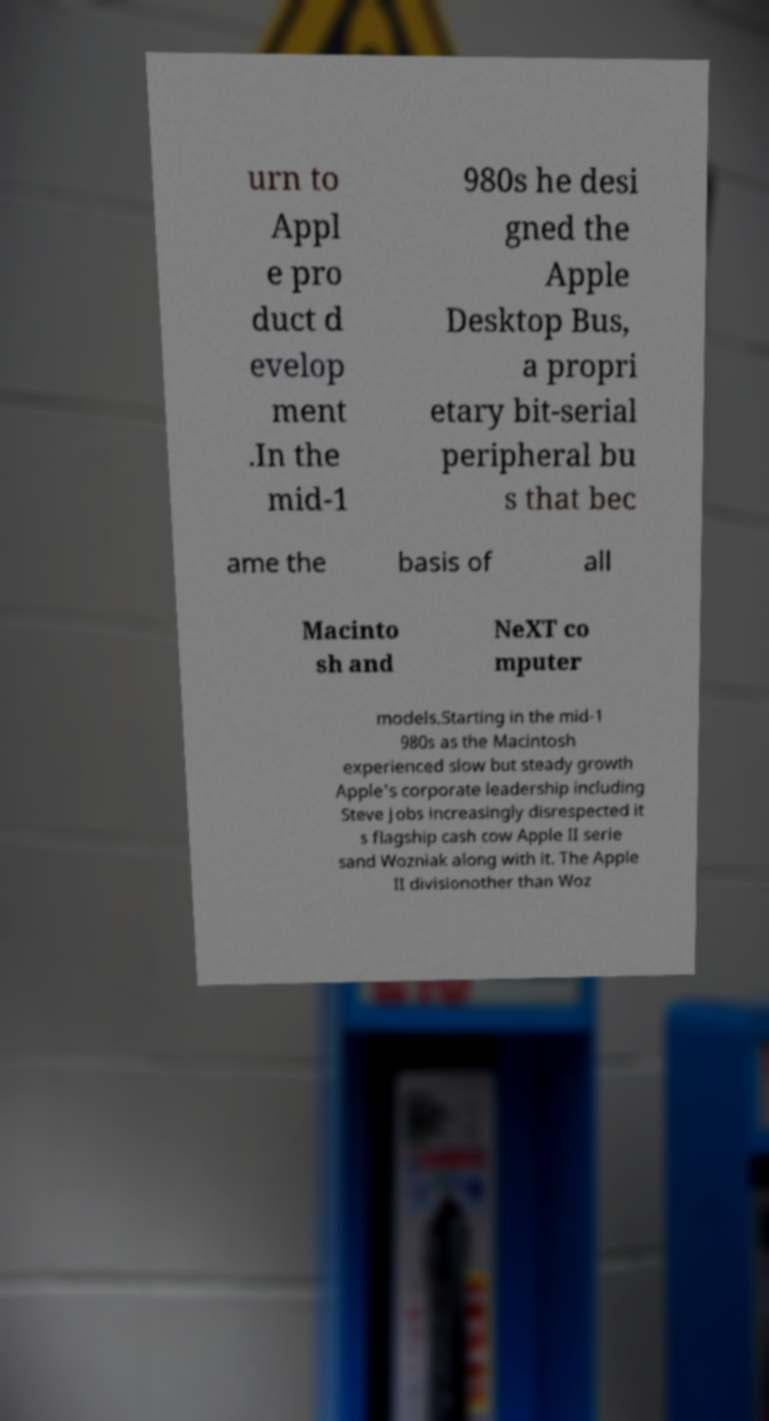I need the written content from this picture converted into text. Can you do that? urn to Appl e pro duct d evelop ment .In the mid-1 980s he desi gned the Apple Desktop Bus, a propri etary bit-serial peripheral bu s that bec ame the basis of all Macinto sh and NeXT co mputer models.Starting in the mid-1 980s as the Macintosh experienced slow but steady growth Apple's corporate leadership including Steve Jobs increasingly disrespected it s flagship cash cow Apple II serie sand Wozniak along with it. The Apple II divisionother than Woz 